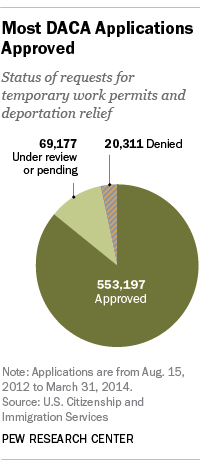Highlight a few significant elements in this photo. The value of "Denial" is the least in the pie chart. According to data provided, 553,197 individuals were approved for work permits and deportation relief. 